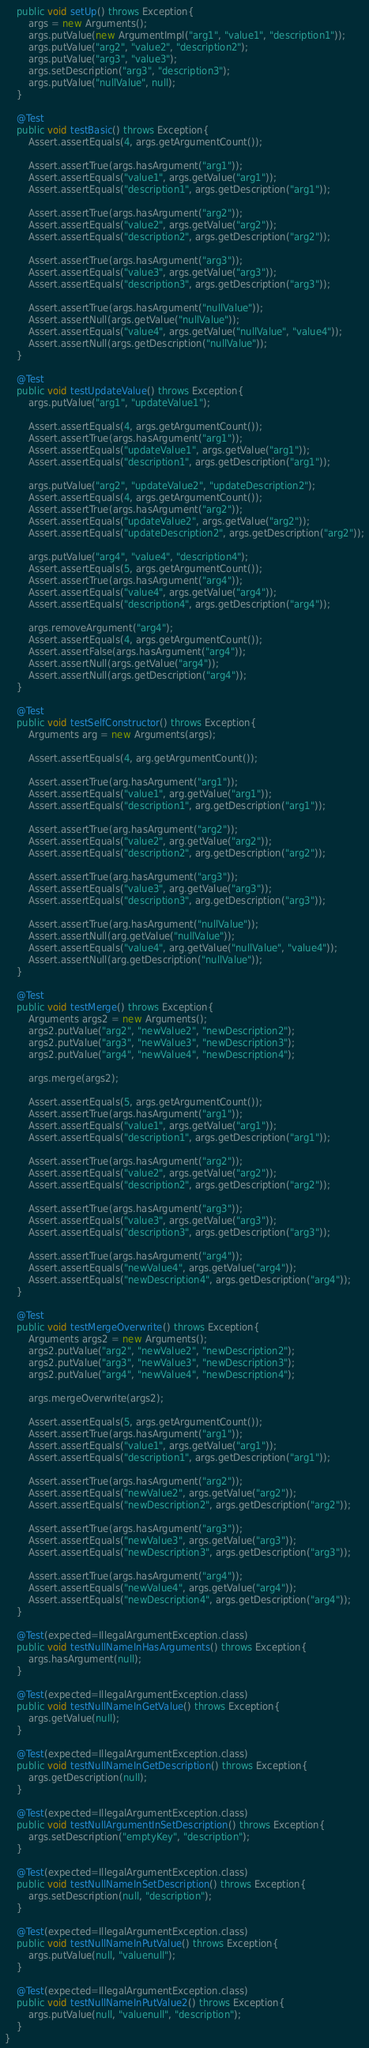Convert code to text. <code><loc_0><loc_0><loc_500><loc_500><_Java_>    public void setUp() throws Exception{
        args = new Arguments();
        args.putValue(new ArgumentImpl("arg1", "value1", "description1"));
        args.putValue("arg2", "value2", "description2");
        args.putValue("arg3", "value3");
        args.setDescription("arg3", "description3");
        args.putValue("nullValue", null);
    }

    @Test
    public void testBasic() throws Exception{
        Assert.assertEquals(4, args.getArgumentCount());

        Assert.assertTrue(args.hasArgument("arg1"));
        Assert.assertEquals("value1", args.getValue("arg1"));
        Assert.assertEquals("description1", args.getDescription("arg1"));

        Assert.assertTrue(args.hasArgument("arg2"));
        Assert.assertEquals("value2", args.getValue("arg2"));
        Assert.assertEquals("description2", args.getDescription("arg2"));

        Assert.assertTrue(args.hasArgument("arg3"));
        Assert.assertEquals("value3", args.getValue("arg3"));
        Assert.assertEquals("description3", args.getDescription("arg3"));

        Assert.assertTrue(args.hasArgument("nullValue"));
        Assert.assertNull(args.getValue("nullValue"));
        Assert.assertEquals("value4", args.getValue("nullValue", "value4"));
        Assert.assertNull(args.getDescription("nullValue"));
    }

    @Test
    public void testUpdateValue() throws Exception{
        args.putValue("arg1", "updateValue1");
        
        Assert.assertEquals(4, args.getArgumentCount());
        Assert.assertTrue(args.hasArgument("arg1"));
        Assert.assertEquals("updateValue1", args.getValue("arg1"));
        Assert.assertEquals("description1", args.getDescription("arg1"));

        args.putValue("arg2", "updateValue2", "updateDescription2");
        Assert.assertEquals(4, args.getArgumentCount());
        Assert.assertTrue(args.hasArgument("arg2"));
        Assert.assertEquals("updateValue2", args.getValue("arg2"));
        Assert.assertEquals("updateDescription2", args.getDescription("arg2"));

        args.putValue("arg4", "value4", "description4");
        Assert.assertEquals(5, args.getArgumentCount());
        Assert.assertTrue(args.hasArgument("arg4"));
        Assert.assertEquals("value4", args.getValue("arg4"));
        Assert.assertEquals("description4", args.getDescription("arg4"));

        args.removeArgument("arg4");
        Assert.assertEquals(4, args.getArgumentCount());
        Assert.assertFalse(args.hasArgument("arg4"));
        Assert.assertNull(args.getValue("arg4"));
        Assert.assertNull(args.getDescription("arg4"));
    }

    @Test
    public void testSelfConstructor() throws Exception{
        Arguments arg = new Arguments(args);
        
        Assert.assertEquals(4, arg.getArgumentCount());

        Assert.assertTrue(arg.hasArgument("arg1"));
        Assert.assertEquals("value1", arg.getValue("arg1"));
        Assert.assertEquals("description1", arg.getDescription("arg1"));

        Assert.assertTrue(arg.hasArgument("arg2"));
        Assert.assertEquals("value2", arg.getValue("arg2"));
        Assert.assertEquals("description2", arg.getDescription("arg2"));

        Assert.assertTrue(arg.hasArgument("arg3"));
        Assert.assertEquals("value3", arg.getValue("arg3"));
        Assert.assertEquals("description3", arg.getDescription("arg3"));

        Assert.assertTrue(arg.hasArgument("nullValue"));
        Assert.assertNull(arg.getValue("nullValue"));
        Assert.assertEquals("value4", arg.getValue("nullValue", "value4"));
        Assert.assertNull(arg.getDescription("nullValue"));
    }

    @Test
    public void testMerge() throws Exception{
        Arguments args2 = new Arguments();
        args2.putValue("arg2", "newValue2", "newDescription2");
        args2.putValue("arg3", "newValue3", "newDescription3");
        args2.putValue("arg4", "newValue4", "newDescription4");

        args.merge(args2);
        
        Assert.assertEquals(5, args.getArgumentCount());
        Assert.assertTrue(args.hasArgument("arg1"));
        Assert.assertEquals("value1", args.getValue("arg1"));
        Assert.assertEquals("description1", args.getDescription("arg1"));

        Assert.assertTrue(args.hasArgument("arg2"));
        Assert.assertEquals("value2", args.getValue("arg2"));
        Assert.assertEquals("description2", args.getDescription("arg2"));

        Assert.assertTrue(args.hasArgument("arg3"));
        Assert.assertEquals("value3", args.getValue("arg3"));
        Assert.assertEquals("description3", args.getDescription("arg3"));

        Assert.assertTrue(args.hasArgument("arg4"));
        Assert.assertEquals("newValue4", args.getValue("arg4"));
        Assert.assertEquals("newDescription4", args.getDescription("arg4"));
    }

    @Test
    public void testMergeOverwrite() throws Exception{
        Arguments args2 = new Arguments();
        args2.putValue("arg2", "newValue2", "newDescription2");
        args2.putValue("arg3", "newValue3", "newDescription3");
        args2.putValue("arg4", "newValue4", "newDescription4");

        args.mergeOverwrite(args2);
        
        Assert.assertEquals(5, args.getArgumentCount());
        Assert.assertTrue(args.hasArgument("arg1"));
        Assert.assertEquals("value1", args.getValue("arg1"));
        Assert.assertEquals("description1", args.getDescription("arg1"));

        Assert.assertTrue(args.hasArgument("arg2"));
        Assert.assertEquals("newValue2", args.getValue("arg2"));
        Assert.assertEquals("newDescription2", args.getDescription("arg2"));

        Assert.assertTrue(args.hasArgument("arg3"));
        Assert.assertEquals("newValue3", args.getValue("arg3"));
        Assert.assertEquals("newDescription3", args.getDescription("arg3"));

        Assert.assertTrue(args.hasArgument("arg4"));
        Assert.assertEquals("newValue4", args.getValue("arg4"));
        Assert.assertEquals("newDescription4", args.getDescription("arg4"));
    }

    @Test(expected=IllegalArgumentException.class)
    public void testNullNameInHasArguments() throws Exception{
        args.hasArgument(null);
    }

    @Test(expected=IllegalArgumentException.class)
    public void testNullNameInGetValue() throws Exception{
        args.getValue(null);
    }
    
    @Test(expected=IllegalArgumentException.class)
    public void testNullNameInGetDescription() throws Exception{
        args.getDescription(null);
    }

    @Test(expected=IllegalArgumentException.class)
    public void testNullArgumentInSetDescription() throws Exception{
        args.setDescription("emptyKey", "description");
    }

    @Test(expected=IllegalArgumentException.class)
    public void testNullNameInSetDescription() throws Exception{
        args.setDescription(null, "description");
    }

    @Test(expected=IllegalArgumentException.class)
    public void testNullNameInPutValue() throws Exception{
        args.putValue(null, "valuenull");
    }

    @Test(expected=IllegalArgumentException.class)
    public void testNullNameInPutValue2() throws Exception{
        args.putValue(null, "valuenull", "description");
    }
}
</code> 